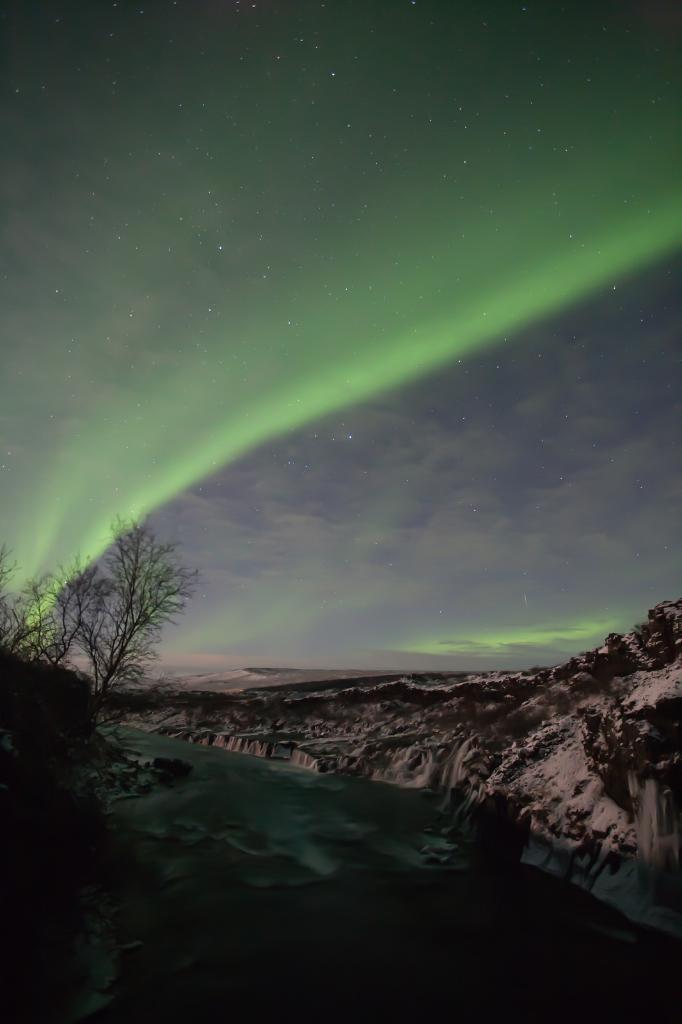Describe this image in one or two sentences. On the left side, there are trees on the hill near the water of a river. On the right side, there is a snow hill. In the background, there are clouds and stars in the sky. 